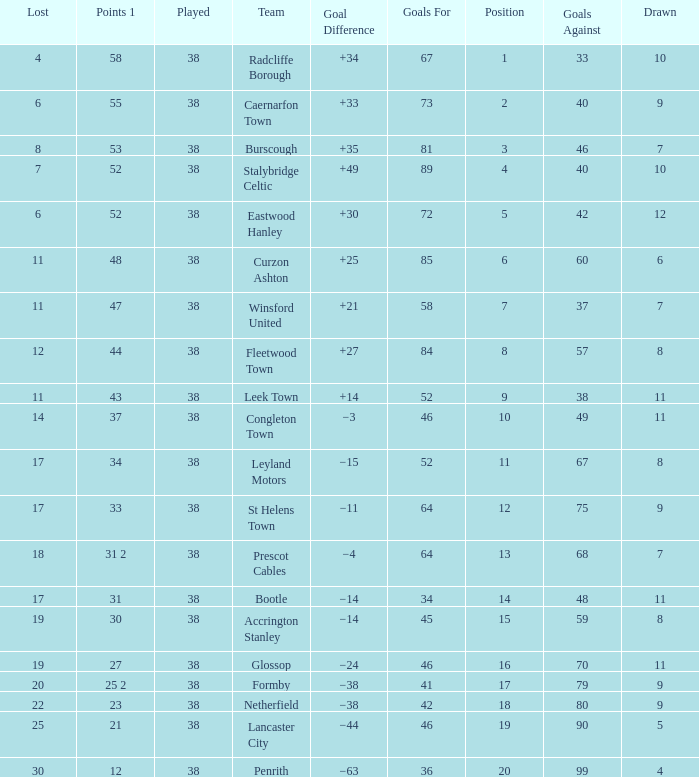WHAT IS THE SUM PLAYED WITH POINTS 1 OF 53, AND POSITION LARGER THAN 3? None. 